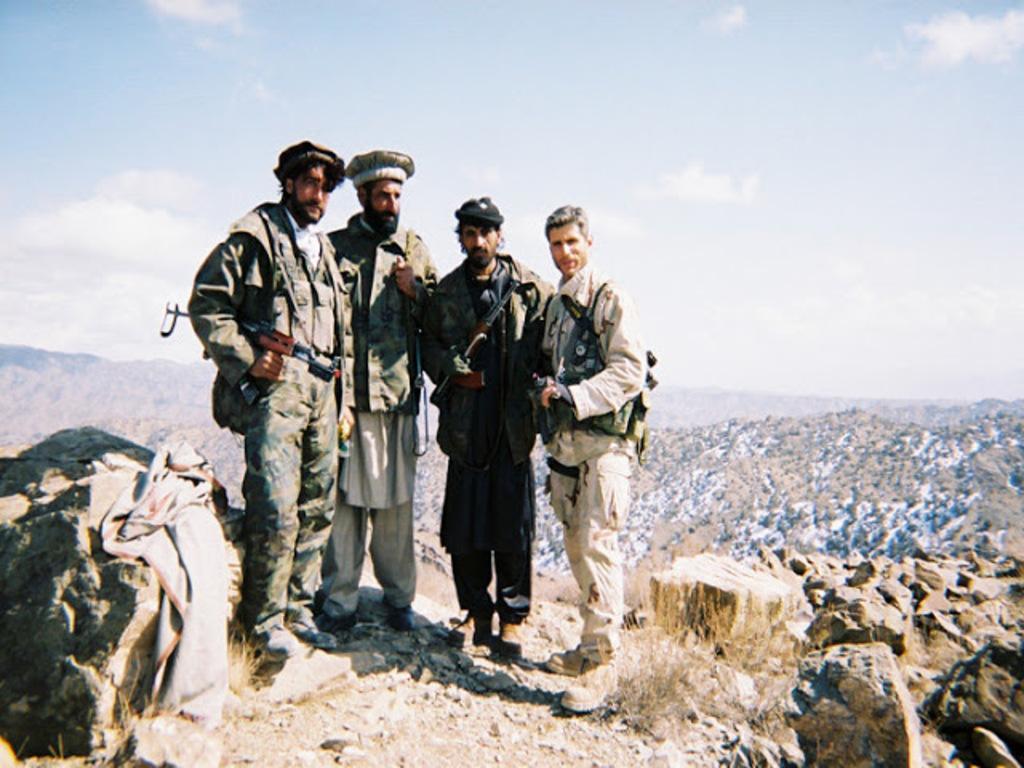Describe this image in one or two sentences. In this image, we can see people wearing uniforms and caps and are holding guns. In the background, there are hills and we can see rocks and there is a shawl. 